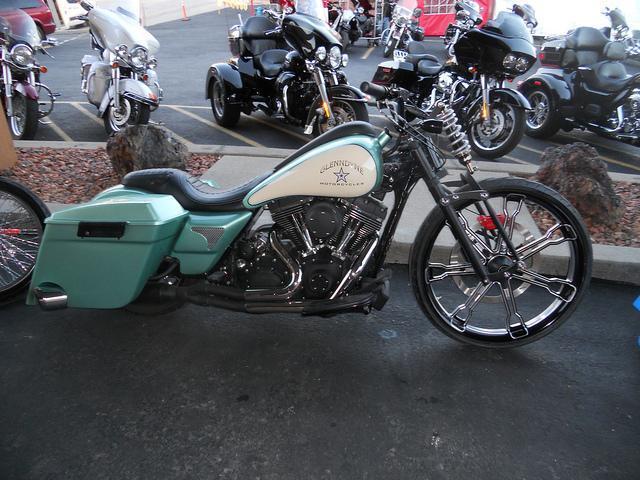How many people can ride this bike at the same time?
Give a very brief answer. 2. How many motorcycles are there?
Give a very brief answer. 7. 